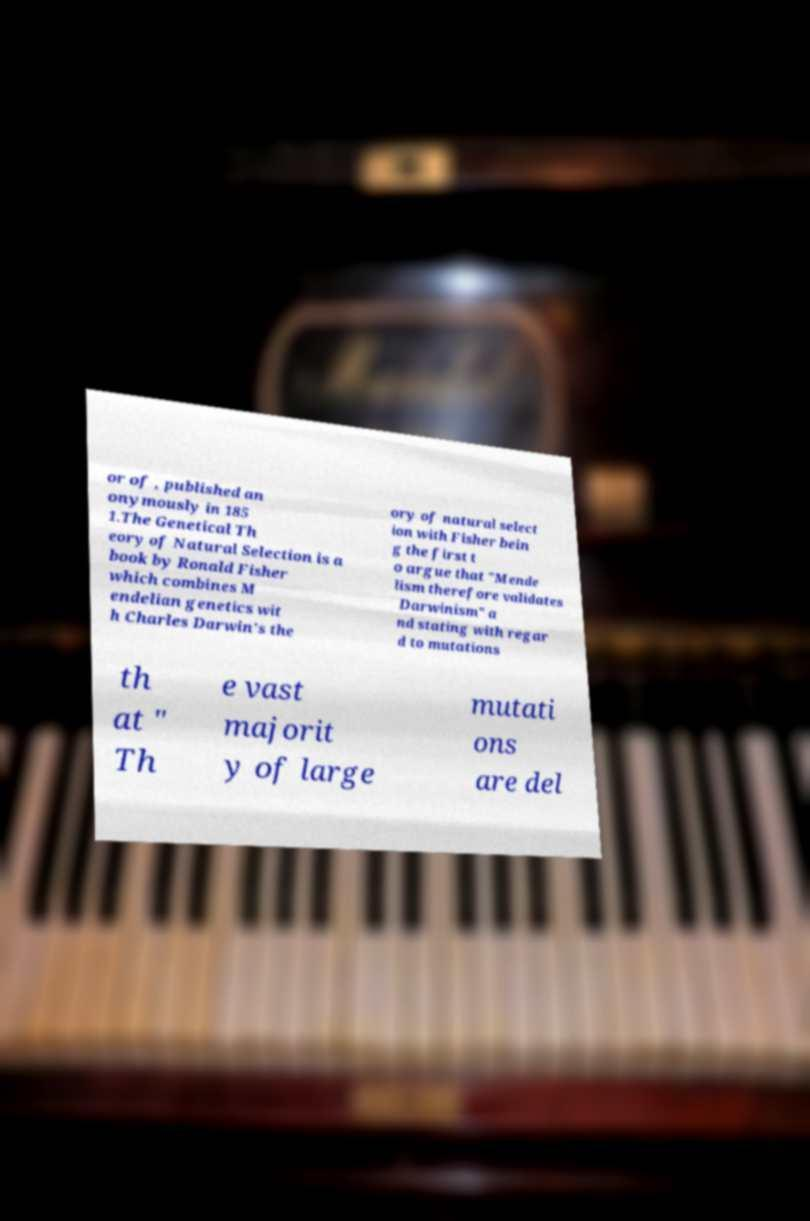Please identify and transcribe the text found in this image. or of , published an onymously in 185 1.The Genetical Th eory of Natural Selection is a book by Ronald Fisher which combines M endelian genetics wit h Charles Darwin's the ory of natural select ion with Fisher bein g the first t o argue that "Mende lism therefore validates Darwinism" a nd stating with regar d to mutations th at " Th e vast majorit y of large mutati ons are del 